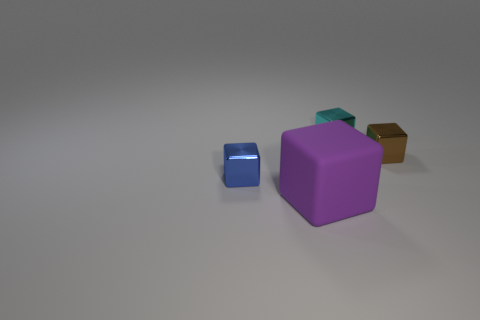Subtract all purple rubber cubes. How many cubes are left? 3 Add 2 tiny blue cubes. How many objects exist? 6 Add 2 purple matte things. How many purple matte things exist? 3 Subtract all cyan cubes. How many cubes are left? 3 Subtract 1 purple blocks. How many objects are left? 3 Subtract 4 cubes. How many cubes are left? 0 Subtract all red blocks. Subtract all purple balls. How many blocks are left? 4 Subtract all large red spheres. Subtract all metal blocks. How many objects are left? 1 Add 1 blue cubes. How many blue cubes are left? 2 